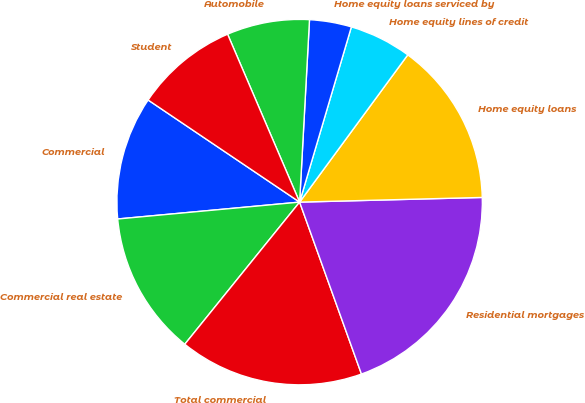Convert chart to OTSL. <chart><loc_0><loc_0><loc_500><loc_500><pie_chart><fcel>Commercial<fcel>Commercial real estate<fcel>Total commercial<fcel>Residential mortgages<fcel>Home equity loans<fcel>Home equity lines of credit<fcel>Home equity loans serviced by<fcel>Automobile<fcel>Student<nl><fcel>10.91%<fcel>12.71%<fcel>16.31%<fcel>19.91%<fcel>14.51%<fcel>5.51%<fcel>3.71%<fcel>7.31%<fcel>9.11%<nl></chart> 